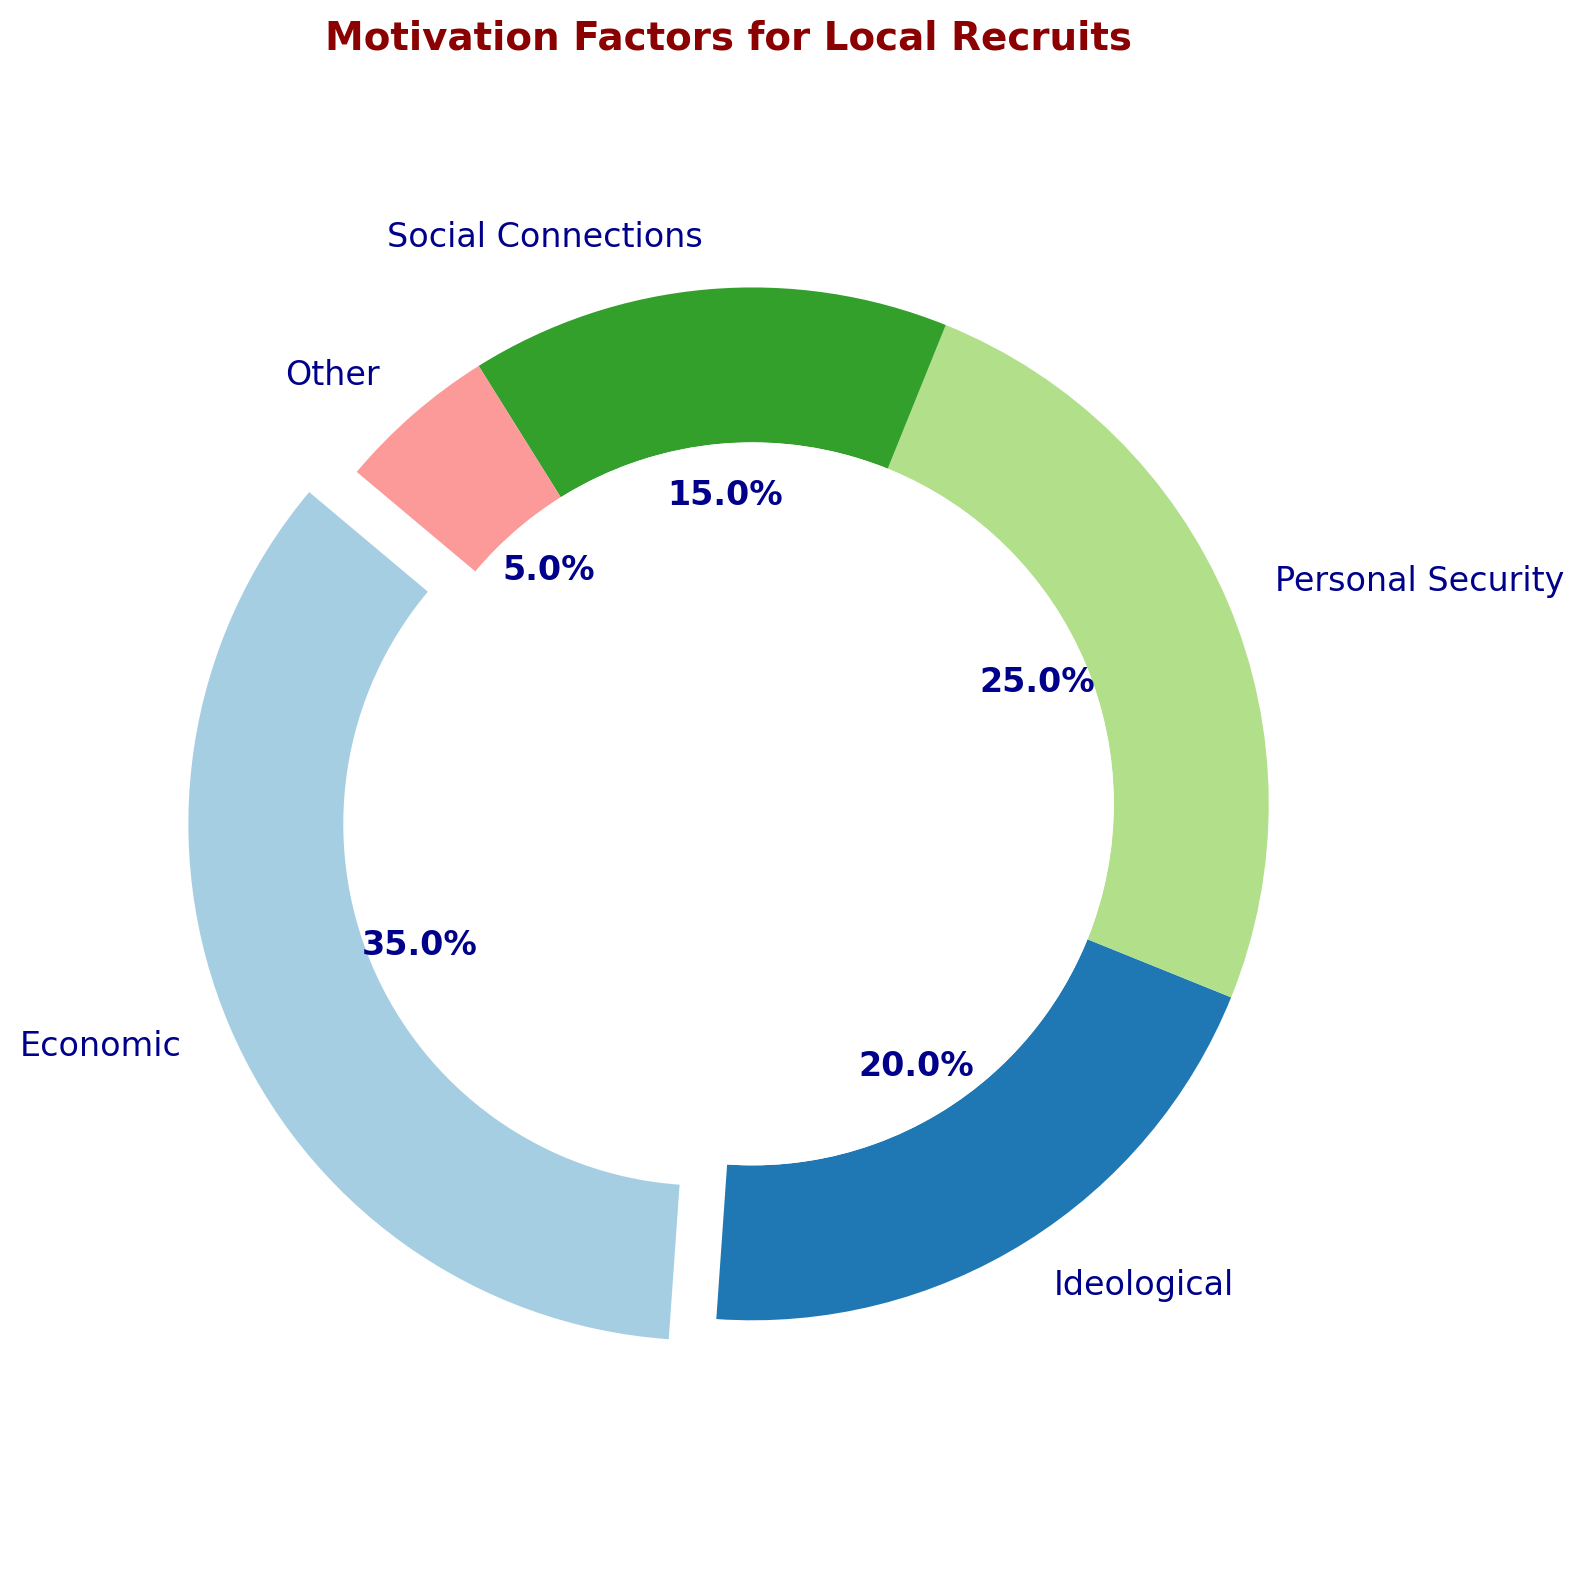What is the largest contributing factor to local recruit motivation? By looking at the segment sizes in the ring chart, the "Economic" factor represents the largest slice, with a percentage of 35%.
Answer: Economic Which two factors have the smallest contributions combined? The "Social Connections" factor has a percentage of 15%, and "Other" has a percentage of 5%. Adding these together gives 15% + 5% = 20%.
Answer: Social Connections and Other How much more significant is the Economic factor compared to the Ideological factor? The percentage for the Economic factor is 35%, and for the Ideological factor, it is 20%. The difference between these percentages is 35% - 20% = 15%.
Answer: 15% If you sum the percentages of the Personal Security and Social Connections factors, what do you get? The percentage for Personal Security is 25%, and for Social Connections, it is 15%. Adding these together gives 25% + 15% = 40%.
Answer: 40% Which factor is the second largest in terms of contribution percentage? By comparing the sizes of the slices, the "Personal Security" factor is the second largest, with a percentage of 25%.
Answer: Personal Security If the Economic factor were reduced by 10 percentage points, which factor would then become the largest? Reducing the Economic factor by 10 percentage points would leave it at 35% - 10% = 25%. This would tie it with Personal Security, making both the largest factors at 25%.
Answer: Economic and Personal Security What is the overall range of percentages in the chart? The highest percentage is 35% for the Economic factor, and the lowest is 5% for the Other factor. The range is calculated as 35% - 5% = 30%.
Answer: 30% How many factors contribute more than 20%? Examining the chart, only "Economic" and "Personal Security" factors contribute more than 20%, representing 35% and 25%, respectively.
Answer: 2 Which factor contributes double the percentage of the Social Connections factor? The "Economic" factor contributes 35%, which is more than double the 15% contribution of the Social Connections factor.
Answer: Economic 